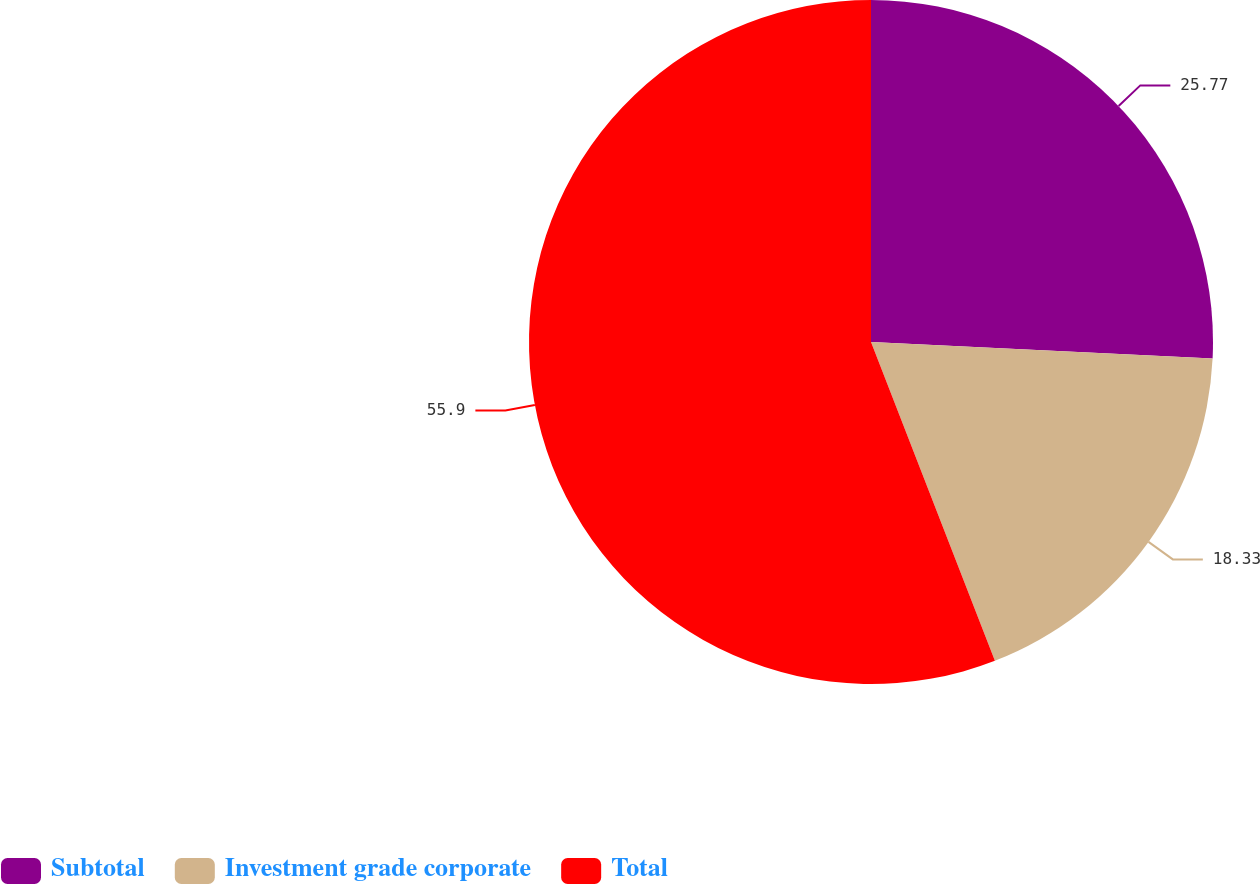Convert chart. <chart><loc_0><loc_0><loc_500><loc_500><pie_chart><fcel>Subtotal<fcel>Investment grade corporate<fcel>Total<nl><fcel>25.77%<fcel>18.33%<fcel>55.9%<nl></chart> 